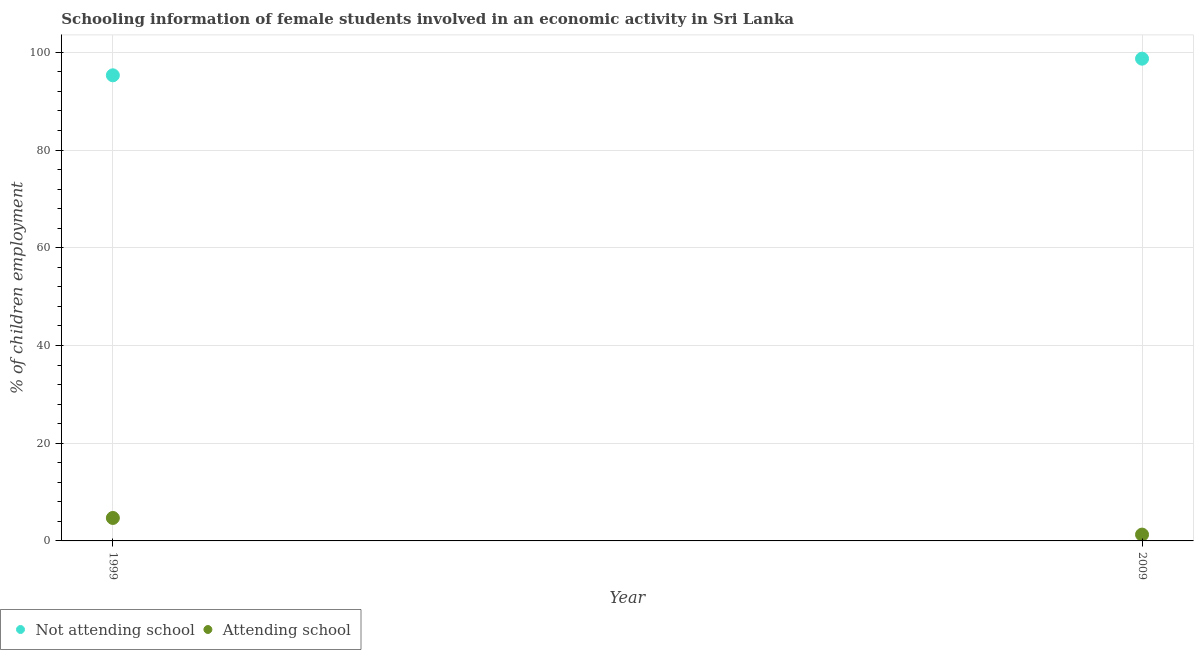Is the number of dotlines equal to the number of legend labels?
Ensure brevity in your answer.  Yes. What is the percentage of employed females who are attending school in 2009?
Your response must be concise. 1.29. Across all years, what is the maximum percentage of employed females who are not attending school?
Provide a short and direct response. 98.71. Across all years, what is the minimum percentage of employed females who are not attending school?
Provide a short and direct response. 95.3. What is the total percentage of employed females who are attending school in the graph?
Your answer should be compact. 5.99. What is the difference between the percentage of employed females who are attending school in 1999 and that in 2009?
Your response must be concise. 3.41. What is the difference between the percentage of employed females who are not attending school in 1999 and the percentage of employed females who are attending school in 2009?
Give a very brief answer. 94.01. What is the average percentage of employed females who are attending school per year?
Offer a very short reply. 3. In the year 2009, what is the difference between the percentage of employed females who are attending school and percentage of employed females who are not attending school?
Offer a terse response. -97.41. What is the ratio of the percentage of employed females who are not attending school in 1999 to that in 2009?
Offer a terse response. 0.97. In how many years, is the percentage of employed females who are not attending school greater than the average percentage of employed females who are not attending school taken over all years?
Offer a terse response. 1. Is the percentage of employed females who are attending school strictly greater than the percentage of employed females who are not attending school over the years?
Give a very brief answer. No. What is the difference between two consecutive major ticks on the Y-axis?
Ensure brevity in your answer.  20. Does the graph contain any zero values?
Provide a short and direct response. No. Where does the legend appear in the graph?
Ensure brevity in your answer.  Bottom left. How many legend labels are there?
Provide a short and direct response. 2. What is the title of the graph?
Provide a succinct answer. Schooling information of female students involved in an economic activity in Sri Lanka. Does "From human activities" appear as one of the legend labels in the graph?
Offer a very short reply. No. What is the label or title of the Y-axis?
Provide a succinct answer. % of children employment. What is the % of children employment in Not attending school in 1999?
Your response must be concise. 95.3. What is the % of children employment in Attending school in 1999?
Provide a short and direct response. 4.7. What is the % of children employment in Not attending school in 2009?
Provide a succinct answer. 98.71. What is the % of children employment of Attending school in 2009?
Offer a very short reply. 1.29. Across all years, what is the maximum % of children employment of Not attending school?
Offer a terse response. 98.71. Across all years, what is the maximum % of children employment in Attending school?
Make the answer very short. 4.7. Across all years, what is the minimum % of children employment in Not attending school?
Ensure brevity in your answer.  95.3. Across all years, what is the minimum % of children employment in Attending school?
Provide a short and direct response. 1.29. What is the total % of children employment in Not attending school in the graph?
Offer a very short reply. 194. What is the total % of children employment in Attending school in the graph?
Provide a short and direct response. 6. What is the difference between the % of children employment in Not attending school in 1999 and that in 2009?
Offer a very short reply. -3.4. What is the difference between the % of children employment in Attending school in 1999 and that in 2009?
Ensure brevity in your answer.  3.4. What is the difference between the % of children employment in Not attending school in 1999 and the % of children employment in Attending school in 2009?
Your answer should be compact. 94. What is the average % of children employment in Not attending school per year?
Provide a short and direct response. 97. What is the average % of children employment of Attending school per year?
Provide a short and direct response. 3. In the year 1999, what is the difference between the % of children employment in Not attending school and % of children employment in Attending school?
Give a very brief answer. 90.6. In the year 2009, what is the difference between the % of children employment in Not attending school and % of children employment in Attending school?
Keep it short and to the point. 97.41. What is the ratio of the % of children employment in Not attending school in 1999 to that in 2009?
Your answer should be very brief. 0.97. What is the ratio of the % of children employment of Attending school in 1999 to that in 2009?
Your response must be concise. 3.63. What is the difference between the highest and the second highest % of children employment in Not attending school?
Your answer should be compact. 3.4. What is the difference between the highest and the second highest % of children employment in Attending school?
Your answer should be compact. 3.4. What is the difference between the highest and the lowest % of children employment of Not attending school?
Offer a terse response. 3.4. What is the difference between the highest and the lowest % of children employment of Attending school?
Your response must be concise. 3.4. 